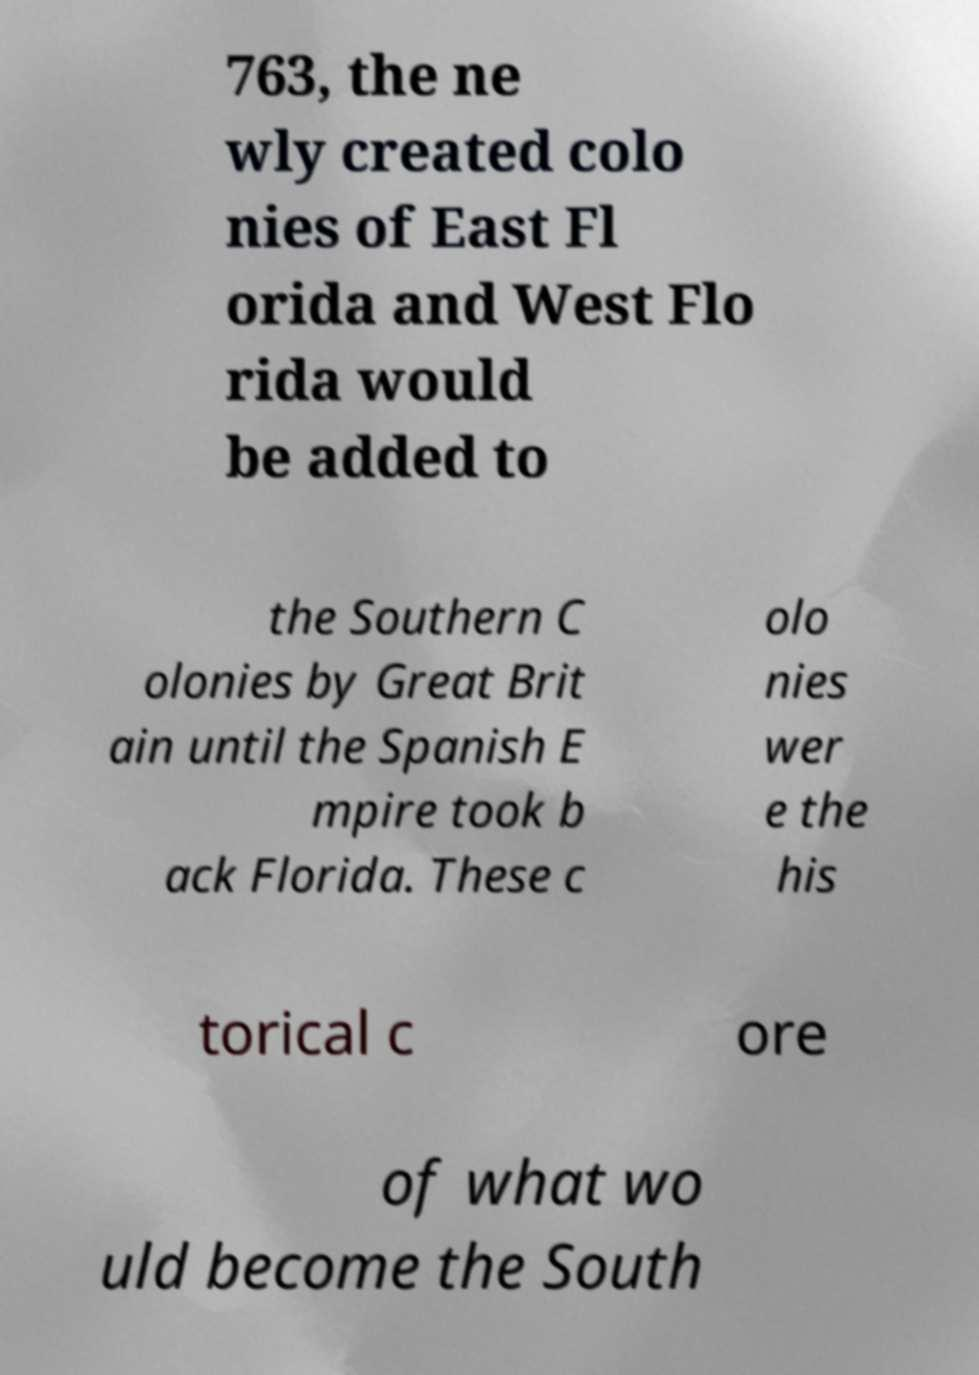Could you extract and type out the text from this image? 763, the ne wly created colo nies of East Fl orida and West Flo rida would be added to the Southern C olonies by Great Brit ain until the Spanish E mpire took b ack Florida. These c olo nies wer e the his torical c ore of what wo uld become the South 